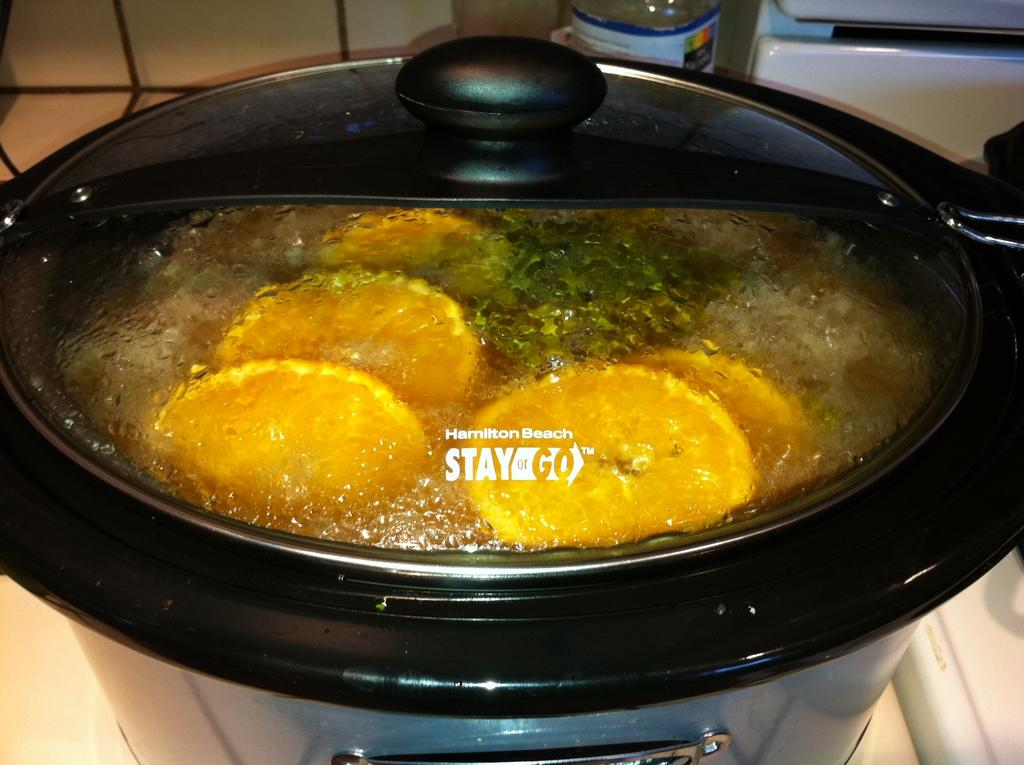<image>
Write a terse but informative summary of the picture. A pan sits on a hob with a lid bearing the logo Hamilton Beach Stay n Go 